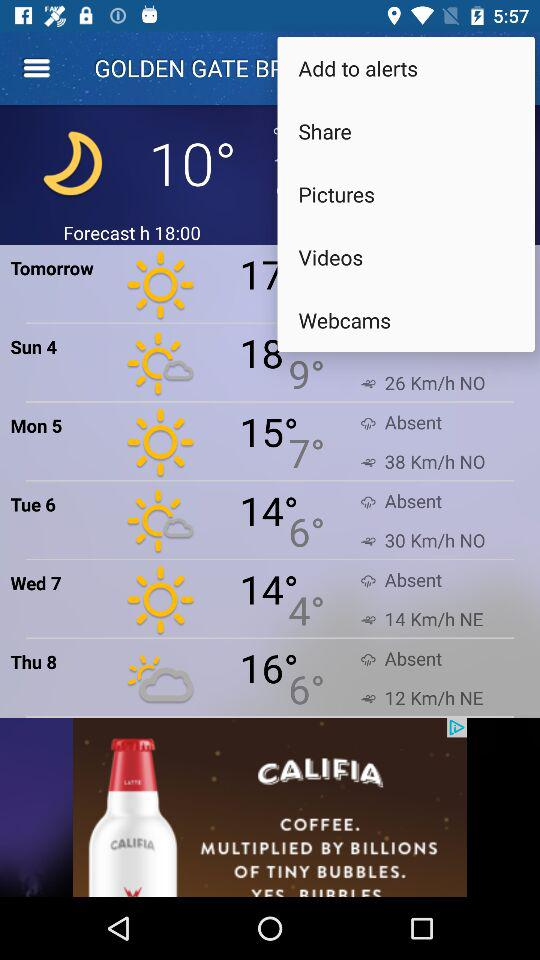What's the current temperature? The current temperature is 10°. 